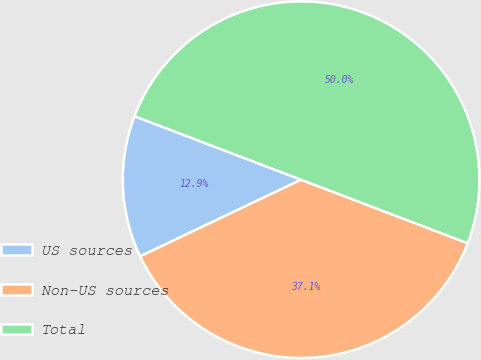<chart> <loc_0><loc_0><loc_500><loc_500><pie_chart><fcel>US sources<fcel>Non-US sources<fcel>Total<nl><fcel>12.87%<fcel>37.13%<fcel>50.0%<nl></chart> 